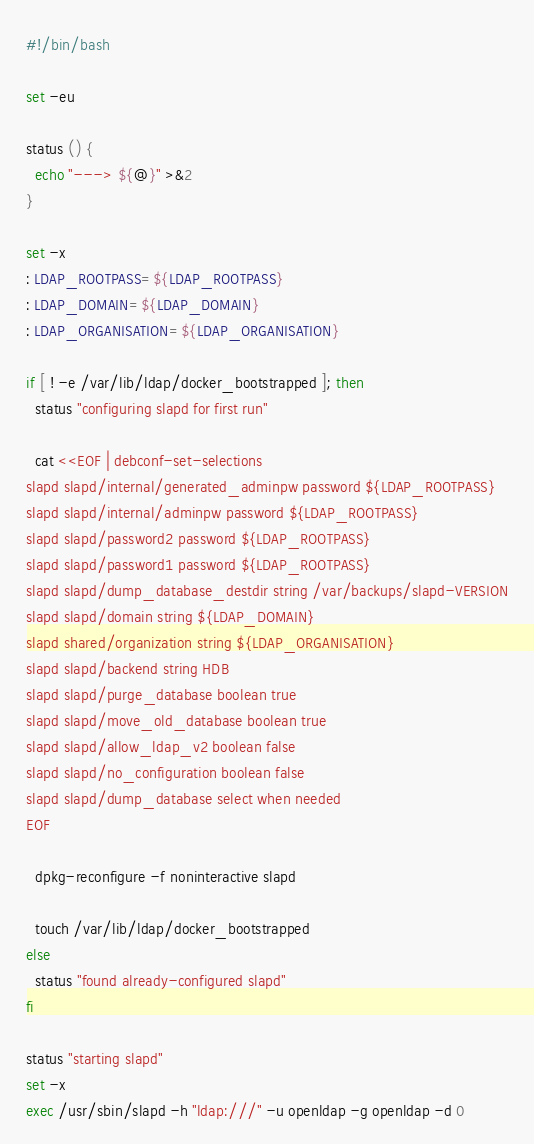Convert code to text. <code><loc_0><loc_0><loc_500><loc_500><_Bash_>#!/bin/bash

set -eu

status () {
  echo "---> ${@}" >&2
}

set -x
: LDAP_ROOTPASS=${LDAP_ROOTPASS}
: LDAP_DOMAIN=${LDAP_DOMAIN}
: LDAP_ORGANISATION=${LDAP_ORGANISATION}

if [ ! -e /var/lib/ldap/docker_bootstrapped ]; then
  status "configuring slapd for first run"

  cat <<EOF | debconf-set-selections
slapd slapd/internal/generated_adminpw password ${LDAP_ROOTPASS}
slapd slapd/internal/adminpw password ${LDAP_ROOTPASS}
slapd slapd/password2 password ${LDAP_ROOTPASS}
slapd slapd/password1 password ${LDAP_ROOTPASS}
slapd slapd/dump_database_destdir string /var/backups/slapd-VERSION
slapd slapd/domain string ${LDAP_DOMAIN}
slapd shared/organization string ${LDAP_ORGANISATION}
slapd slapd/backend string HDB
slapd slapd/purge_database boolean true
slapd slapd/move_old_database boolean true
slapd slapd/allow_ldap_v2 boolean false
slapd slapd/no_configuration boolean false
slapd slapd/dump_database select when needed
EOF

  dpkg-reconfigure -f noninteractive slapd

  touch /var/lib/ldap/docker_bootstrapped
else
  status "found already-configured slapd"
fi

status "starting slapd"
set -x
exec /usr/sbin/slapd -h "ldap:///" -u openldap -g openldap -d 0
</code> 